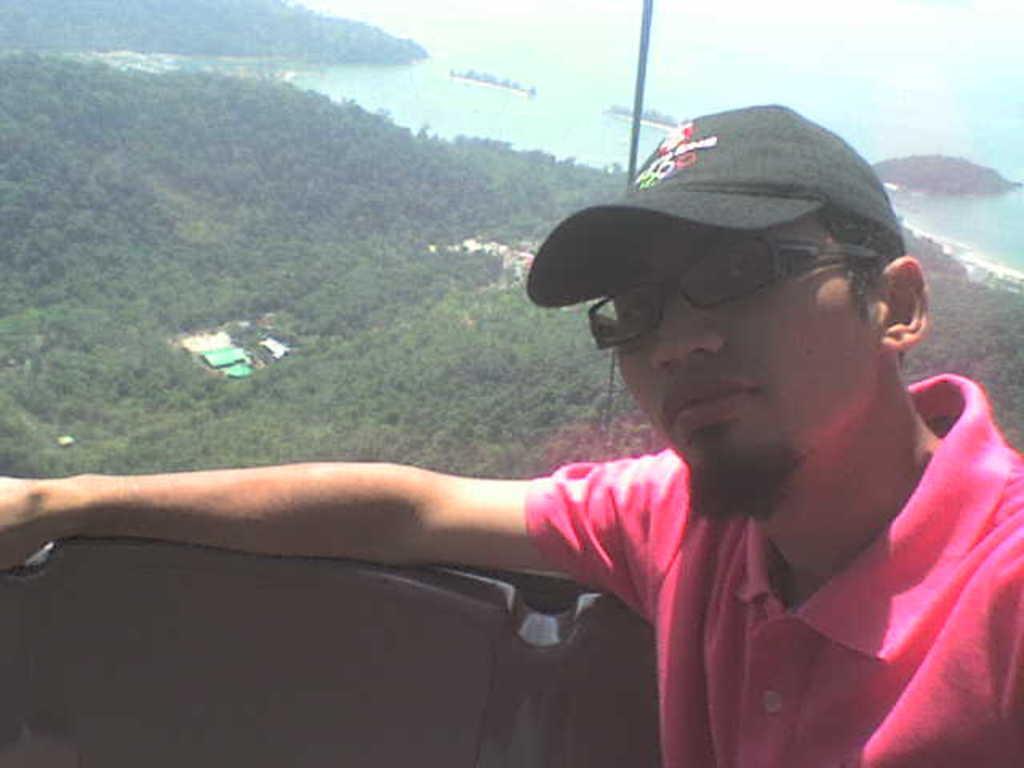Please provide a concise description of this image. In the foreground of this image, there is a man in pink T shirt sitting on the seat and it seems like he is sitting in the cable car. In the background, there are trees, few buildings, water and the cliffs. 